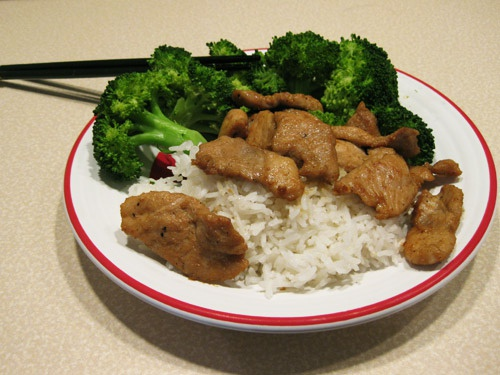Describe the objects in this image and their specific colors. I can see dining table in tan, black, lightgray, and olive tones, broccoli in olive, black, and darkgreen tones, broccoli in olive, black, and darkgreen tones, and broccoli in olive, black, and darkgreen tones in this image. 